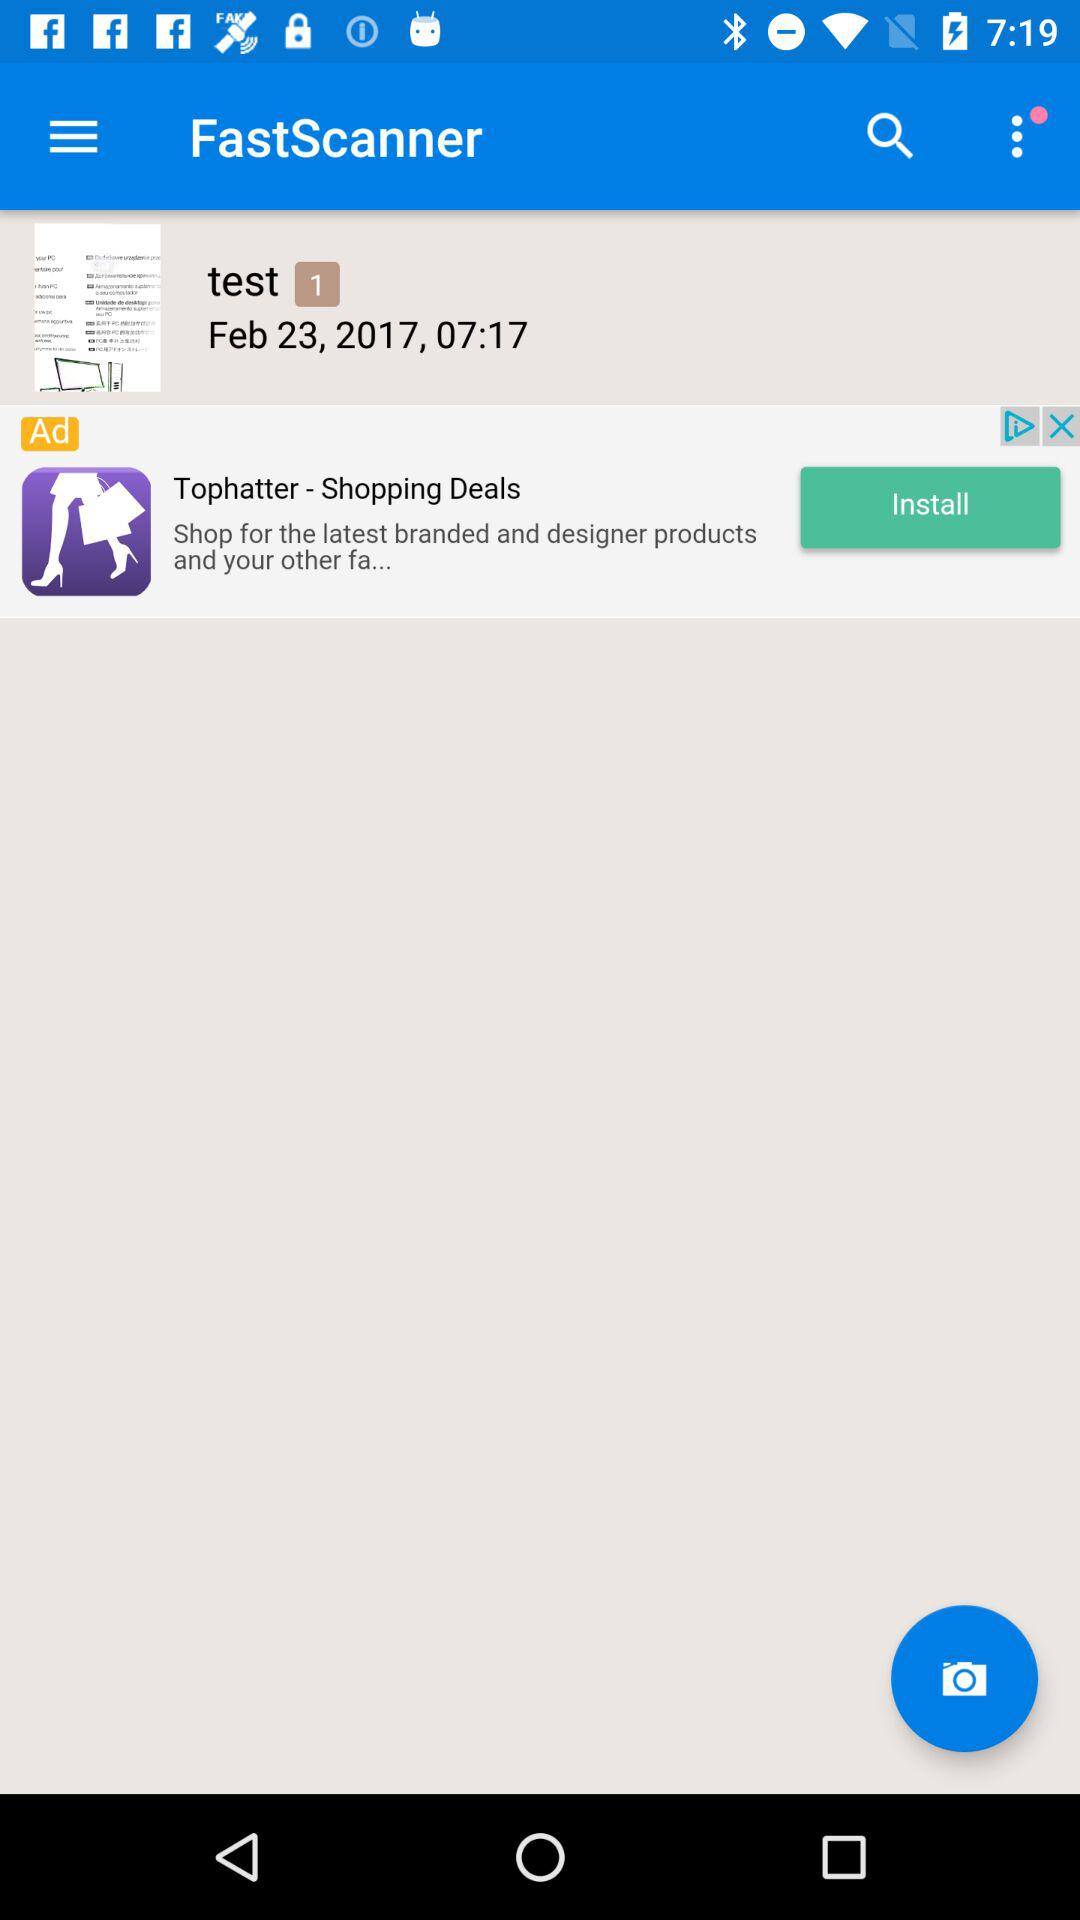At what time is the file "test 1" saved? The file "test 1" is saved at 07:17. 